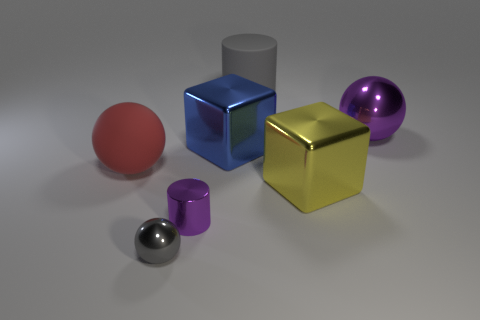Is the big blue object made of the same material as the sphere that is behind the large blue shiny cube?
Provide a succinct answer. Yes. There is a gray sphere that is the same material as the big yellow block; what size is it?
Give a very brief answer. Small. There is a metal object that is behind the big blue metal block; what size is it?
Offer a very short reply. Large. What number of gray shiny blocks have the same size as the red matte thing?
Provide a short and direct response. 0. There is a shiny ball that is the same color as the metallic cylinder; what size is it?
Give a very brief answer. Large. Are there any objects that have the same color as the tiny sphere?
Your response must be concise. Yes. What is the color of the shiny block that is the same size as the yellow object?
Your answer should be compact. Blue. Does the large matte cylinder have the same color as the tiny shiny object in front of the purple cylinder?
Provide a short and direct response. Yes. The rubber ball is what color?
Provide a short and direct response. Red. What is the gray object on the right side of the small cylinder made of?
Offer a terse response. Rubber. 